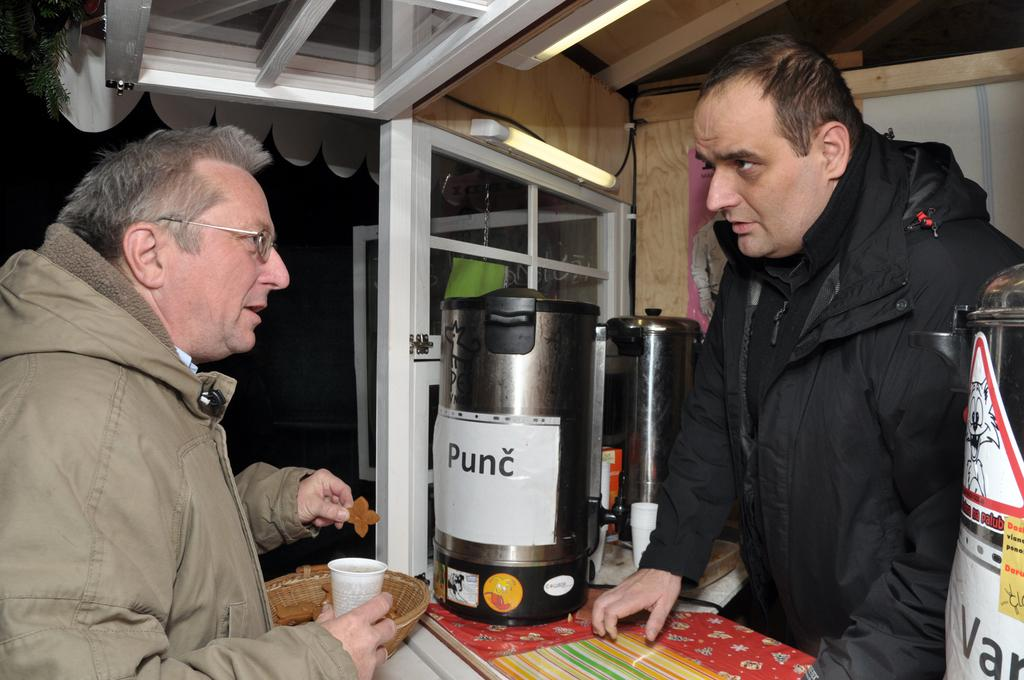<image>
Share a concise interpretation of the image provided. A man standing at a counter holding a cup in front of a punc container. 